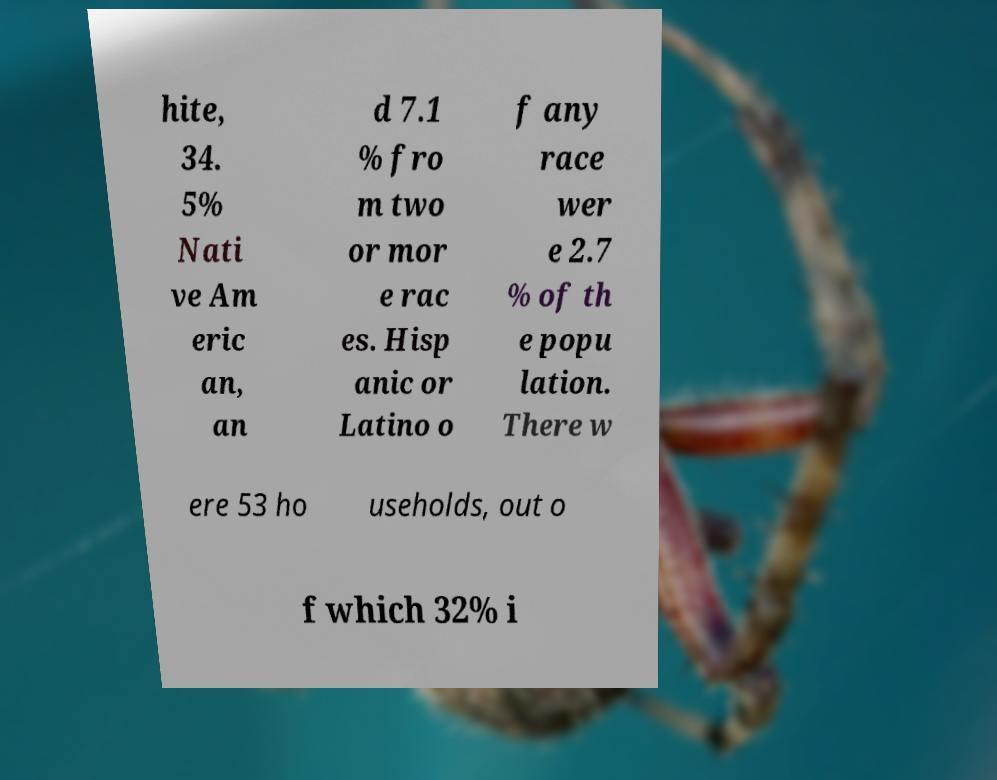For documentation purposes, I need the text within this image transcribed. Could you provide that? hite, 34. 5% Nati ve Am eric an, an d 7.1 % fro m two or mor e rac es. Hisp anic or Latino o f any race wer e 2.7 % of th e popu lation. There w ere 53 ho useholds, out o f which 32% i 